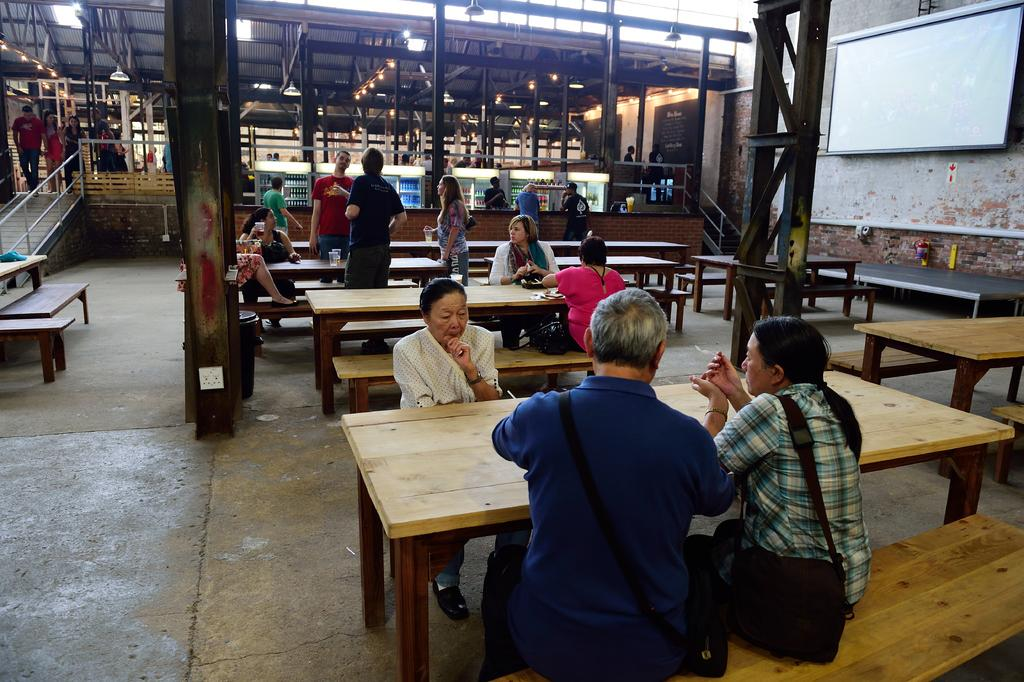What are the people in the image doing? There are people sitting on a bench in the image. What else can be seen in the image besides the people on the bench? There is a table in the image. Are there any other people in the image besides those sitting on the bench? Yes, there are people walking on the floor in the image. What is located on the right side of the image? There is a screen on the right side of the image. What type of ink is being used to draw on the window in the image? There is no window or ink present in the image. Can you describe the face of the person walking on the floor in the image? There is no face visible in the image; only people walking on the floor are mentioned. 